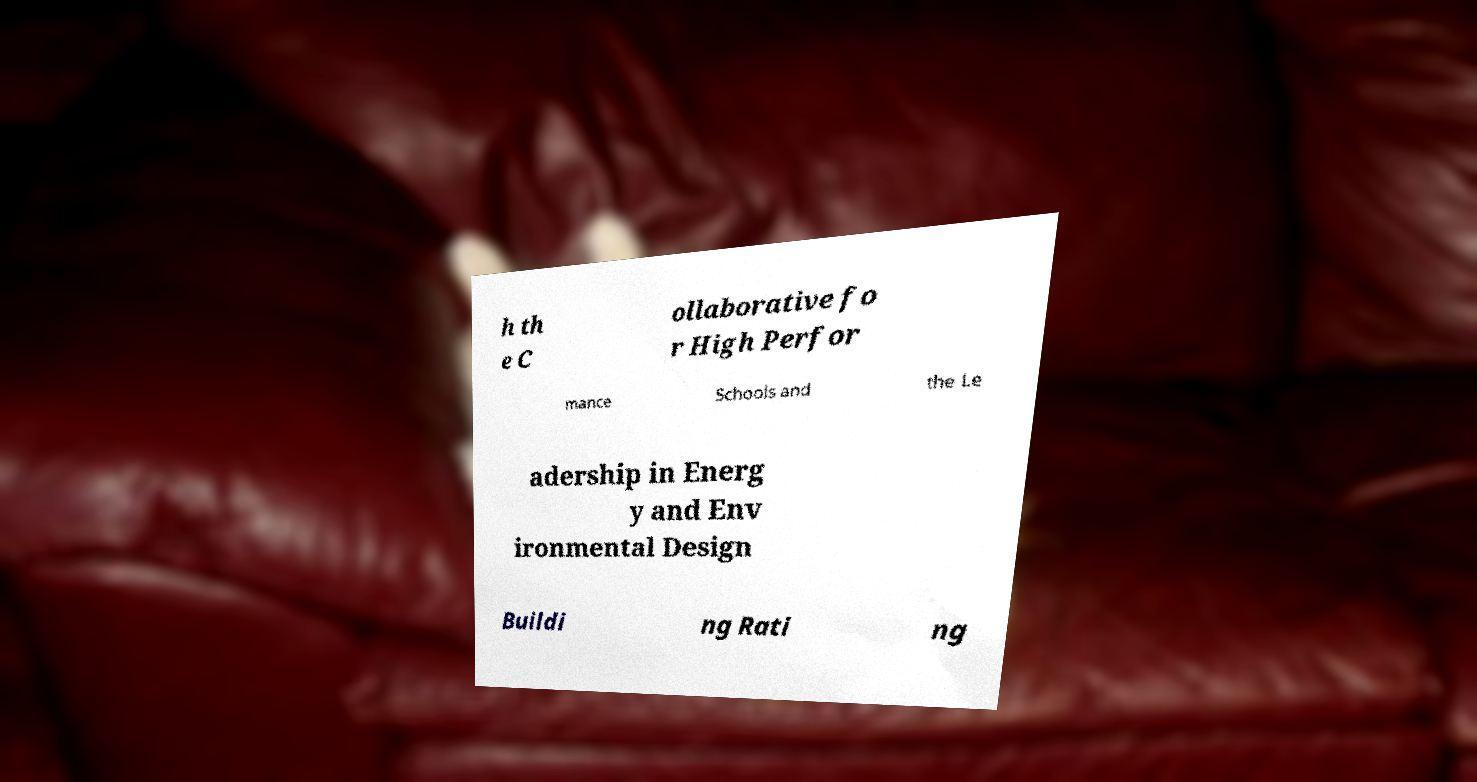Could you assist in decoding the text presented in this image and type it out clearly? h th e C ollaborative fo r High Perfor mance Schools and the Le adership in Energ y and Env ironmental Design Buildi ng Rati ng 